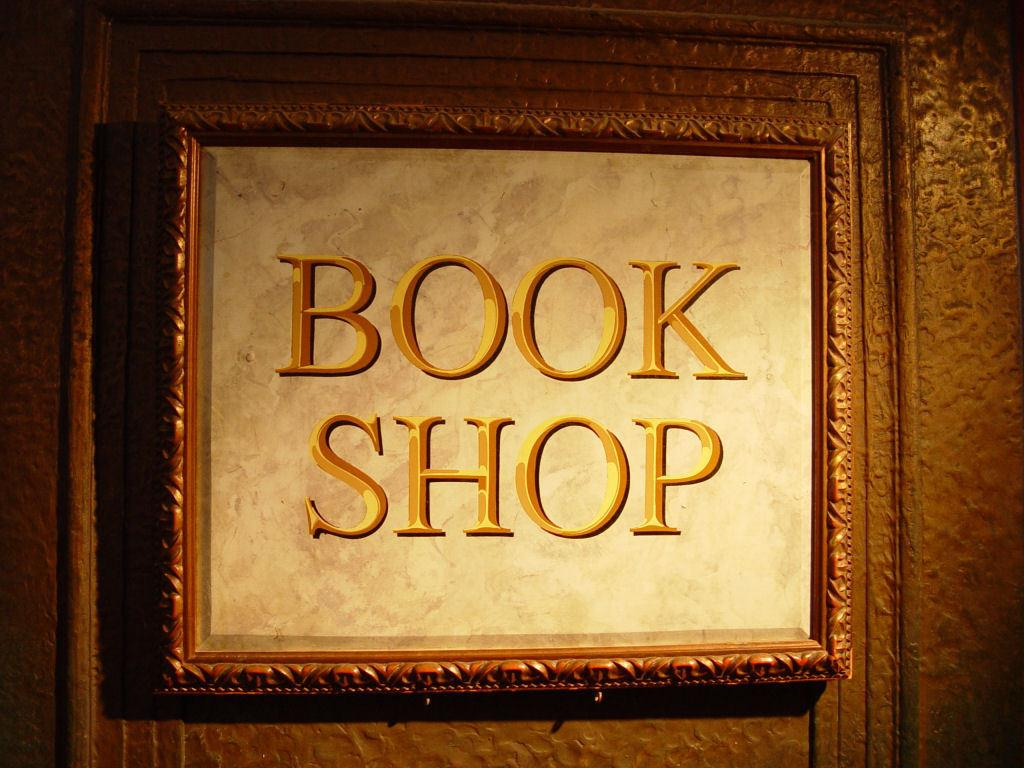Provide a one-sentence caption for the provided image. A sign with the name Book Shop framed in gold with gold lettering. 